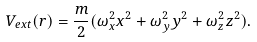Convert formula to latex. <formula><loc_0><loc_0><loc_500><loc_500>V _ { e x t } ( { r } ) = \frac { m } { 2 } ( \omega _ { x } ^ { 2 } x ^ { 2 } + \omega _ { y } ^ { 2 } y ^ { 2 } + \omega _ { z } ^ { 2 } z ^ { 2 } ) .</formula> 